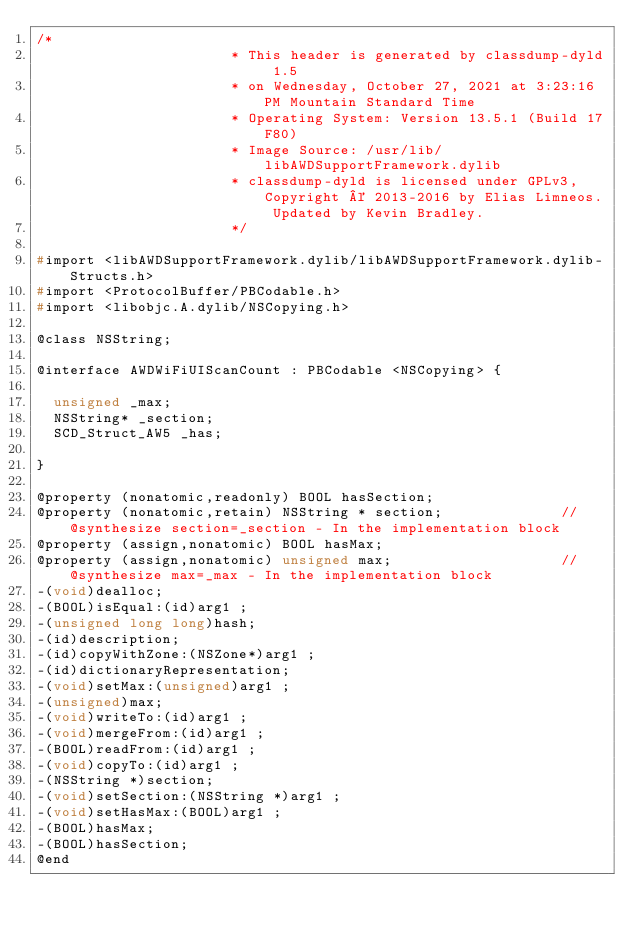<code> <loc_0><loc_0><loc_500><loc_500><_C_>/*
                       * This header is generated by classdump-dyld 1.5
                       * on Wednesday, October 27, 2021 at 3:23:16 PM Mountain Standard Time
                       * Operating System: Version 13.5.1 (Build 17F80)
                       * Image Source: /usr/lib/libAWDSupportFramework.dylib
                       * classdump-dyld is licensed under GPLv3, Copyright © 2013-2016 by Elias Limneos. Updated by Kevin Bradley.
                       */

#import <libAWDSupportFramework.dylib/libAWDSupportFramework.dylib-Structs.h>
#import <ProtocolBuffer/PBCodable.h>
#import <libobjc.A.dylib/NSCopying.h>

@class NSString;

@interface AWDWiFiUIScanCount : PBCodable <NSCopying> {

	unsigned _max;
	NSString* _section;
	SCD_Struct_AW5 _has;

}

@property (nonatomic,readonly) BOOL hasSection; 
@property (nonatomic,retain) NSString * section;              //@synthesize section=_section - In the implementation block
@property (assign,nonatomic) BOOL hasMax; 
@property (assign,nonatomic) unsigned max;                    //@synthesize max=_max - In the implementation block
-(void)dealloc;
-(BOOL)isEqual:(id)arg1 ;
-(unsigned long long)hash;
-(id)description;
-(id)copyWithZone:(NSZone*)arg1 ;
-(id)dictionaryRepresentation;
-(void)setMax:(unsigned)arg1 ;
-(unsigned)max;
-(void)writeTo:(id)arg1 ;
-(void)mergeFrom:(id)arg1 ;
-(BOOL)readFrom:(id)arg1 ;
-(void)copyTo:(id)arg1 ;
-(NSString *)section;
-(void)setSection:(NSString *)arg1 ;
-(void)setHasMax:(BOOL)arg1 ;
-(BOOL)hasMax;
-(BOOL)hasSection;
@end

</code> 